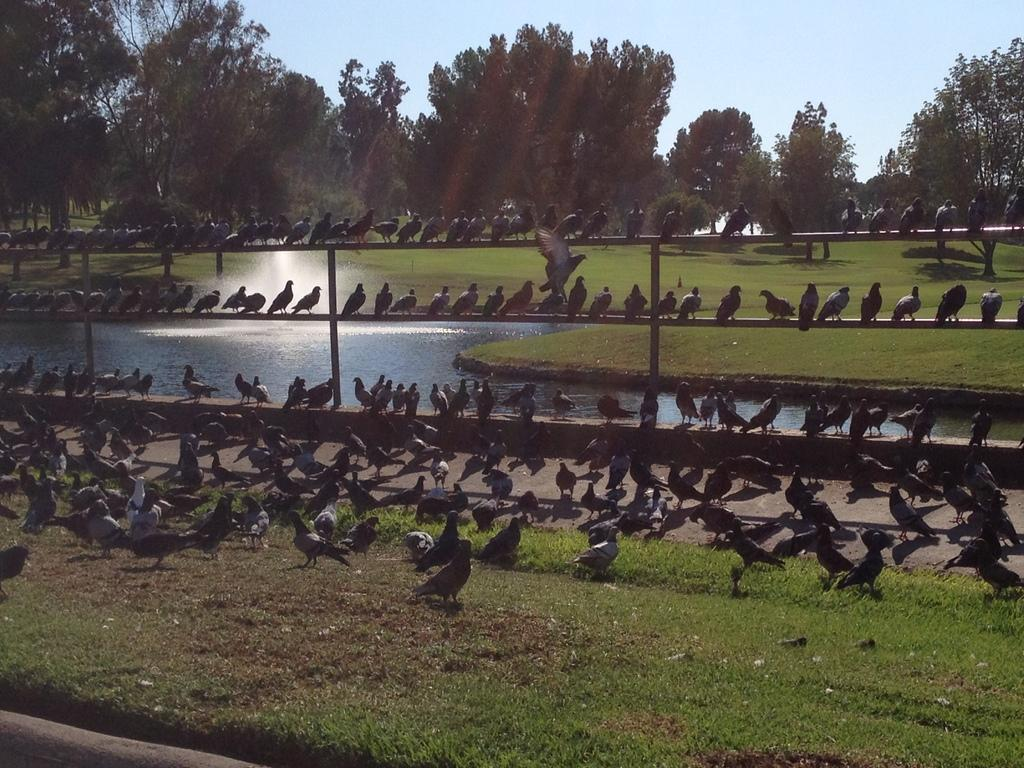What type of animals can be seen in the image? Birds can be seen in the image. Where are some of the birds located? Some birds are on the ground, and some are sitting on a fence. What can be seen in the background of the image? Grass, water, trees, and the sky are visible in the background of the image. What type of bait is being used to attract the birds in the image? There is no bait present in the image; the birds are simply visible in their natural environment. 